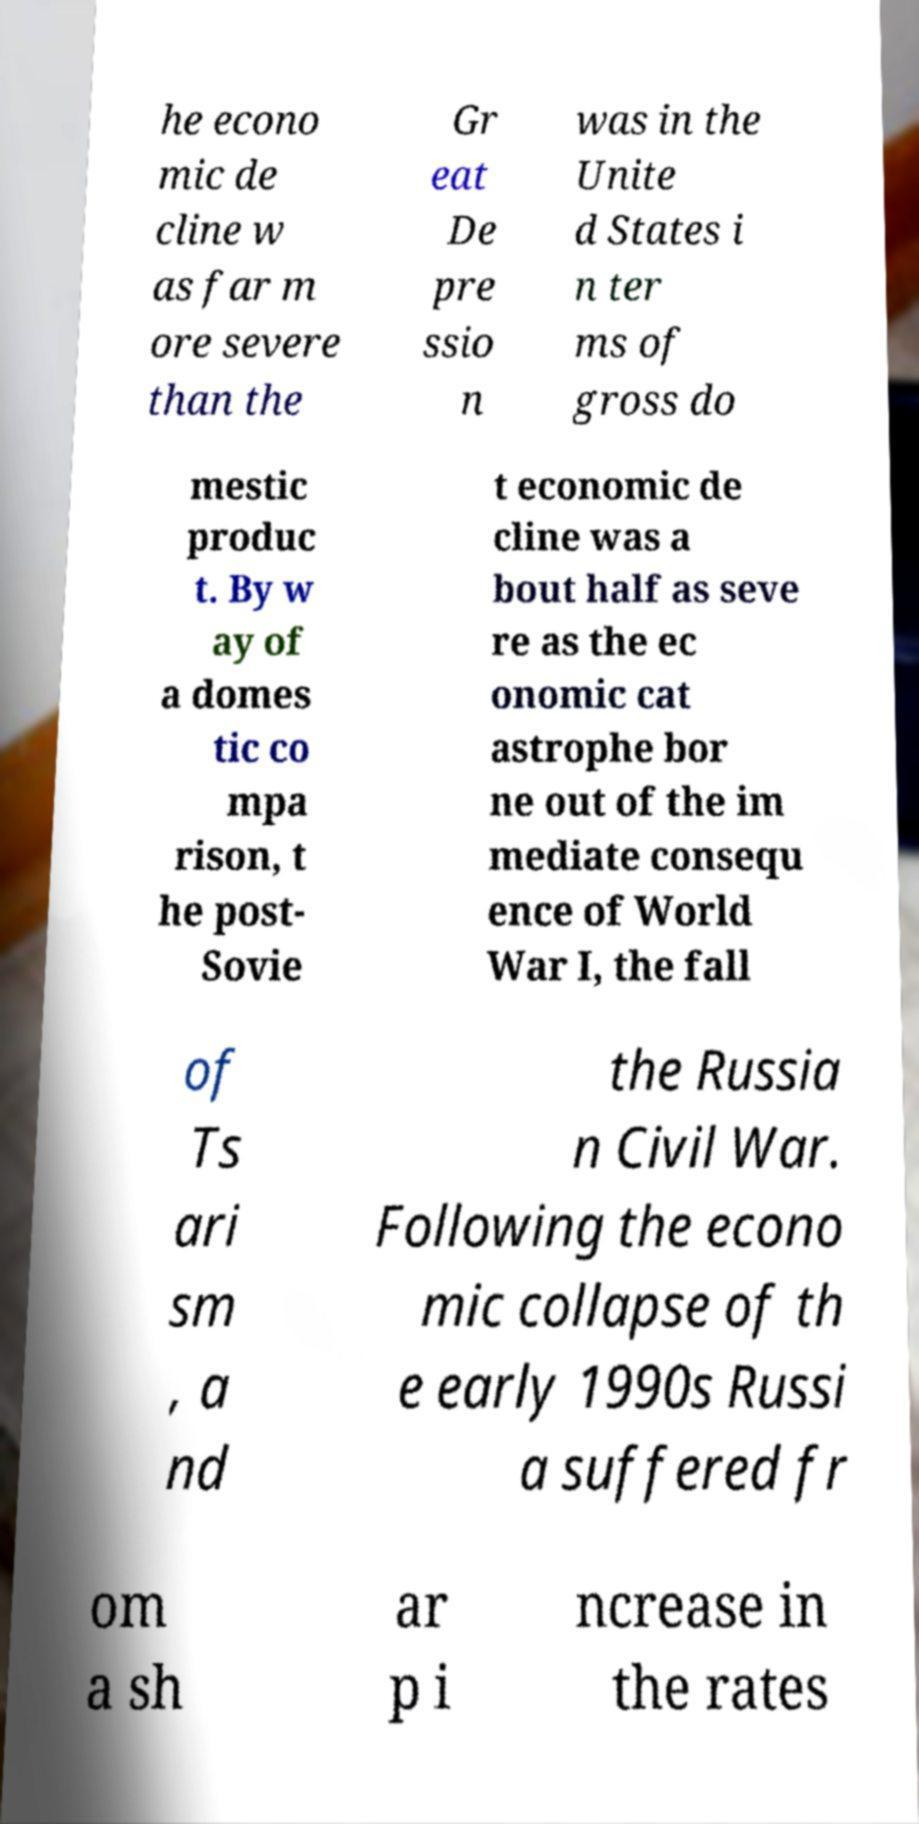Could you assist in decoding the text presented in this image and type it out clearly? he econo mic de cline w as far m ore severe than the Gr eat De pre ssio n was in the Unite d States i n ter ms of gross do mestic produc t. By w ay of a domes tic co mpa rison, t he post- Sovie t economic de cline was a bout half as seve re as the ec onomic cat astrophe bor ne out of the im mediate consequ ence of World War I, the fall of Ts ari sm , a nd the Russia n Civil War. Following the econo mic collapse of th e early 1990s Russi a suffered fr om a sh ar p i ncrease in the rates 